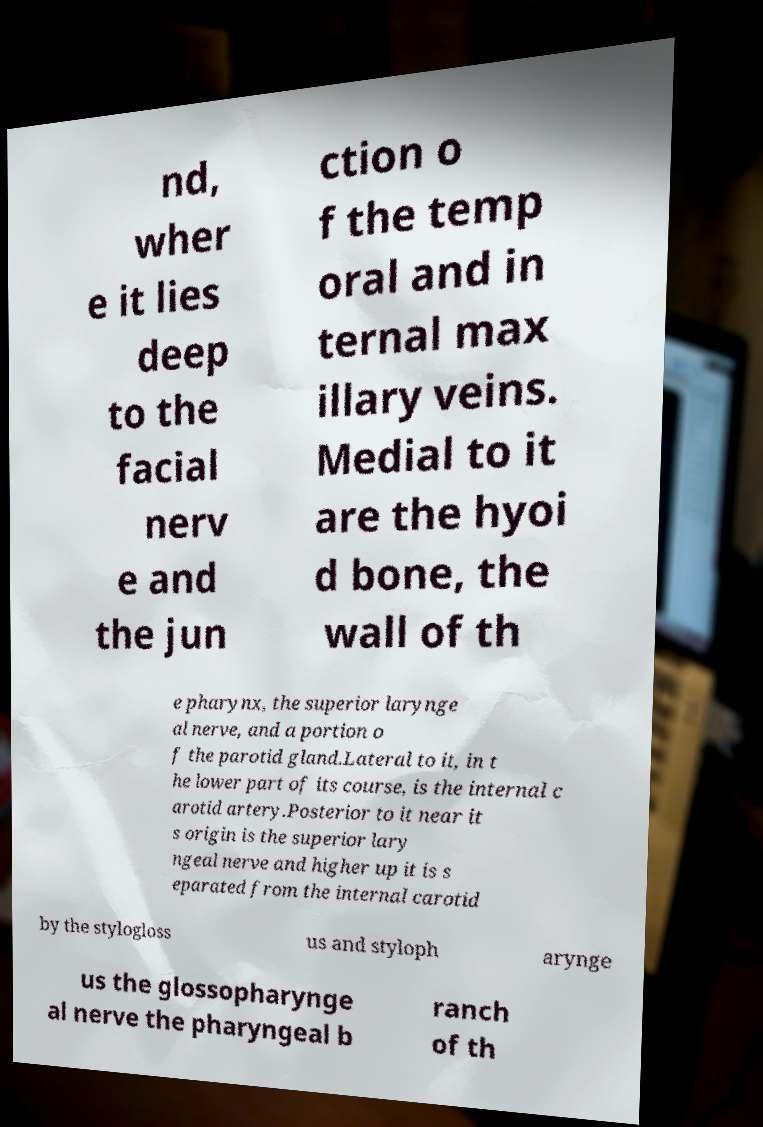I need the written content from this picture converted into text. Can you do that? nd, wher e it lies deep to the facial nerv e and the jun ction o f the temp oral and in ternal max illary veins. Medial to it are the hyoi d bone, the wall of th e pharynx, the superior larynge al nerve, and a portion o f the parotid gland.Lateral to it, in t he lower part of its course, is the internal c arotid artery.Posterior to it near it s origin is the superior lary ngeal nerve and higher up it is s eparated from the internal carotid by the stylogloss us and styloph arynge us the glossopharynge al nerve the pharyngeal b ranch of th 